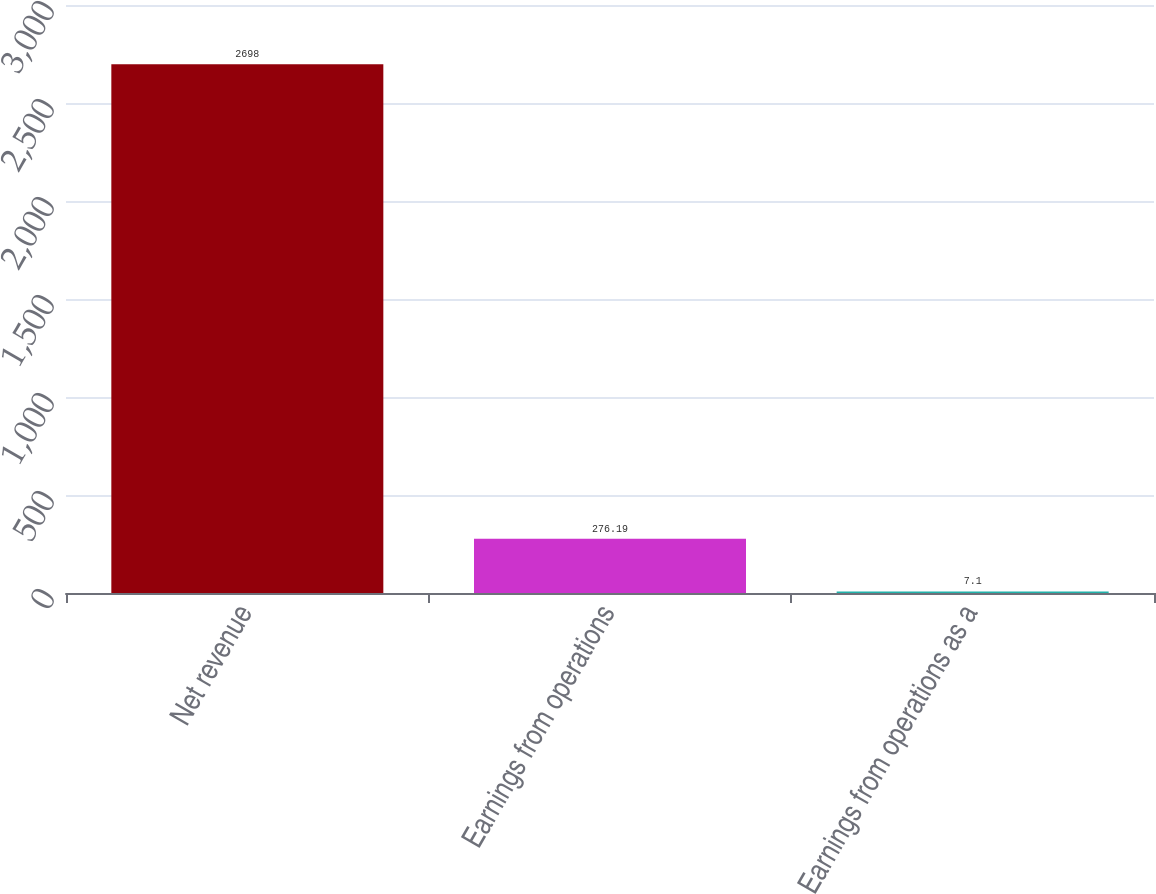Convert chart. <chart><loc_0><loc_0><loc_500><loc_500><bar_chart><fcel>Net revenue<fcel>Earnings from operations<fcel>Earnings from operations as a<nl><fcel>2698<fcel>276.19<fcel>7.1<nl></chart> 